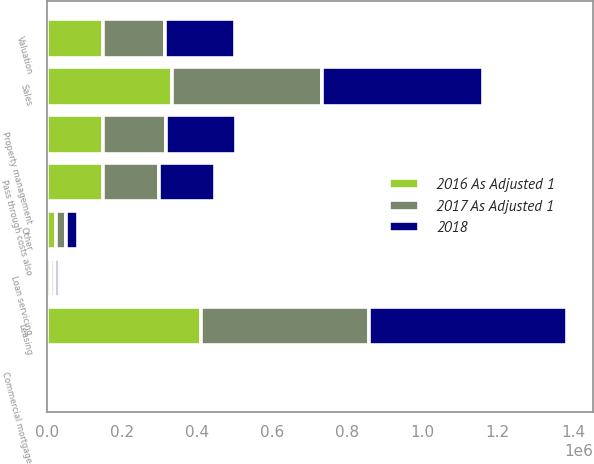<chart> <loc_0><loc_0><loc_500><loc_500><stacked_bar_chart><ecel><fcel>Property management<fcel>Valuation<fcel>Loan servicing<fcel>Leasing<fcel>Sales<fcel>Commercial mortgage<fcel>Other<fcel>Pass through costs also<nl><fcel>2018<fcel>185260<fcel>187515<fcel>10755<fcel>526372<fcel>428810<fcel>5768<fcel>32076<fcel>148982<nl><fcel>2017 As Adjusted 1<fcel>168710<fcel>165082<fcel>10989<fcel>446446<fcel>397130<fcel>5447<fcel>26583<fcel>148982<nl><fcel>2016 As Adjusted 1<fcel>148982<fcel>148856<fcel>11144<fcel>411005<fcel>334398<fcel>2881<fcel>23612<fcel>148982<nl></chart> 